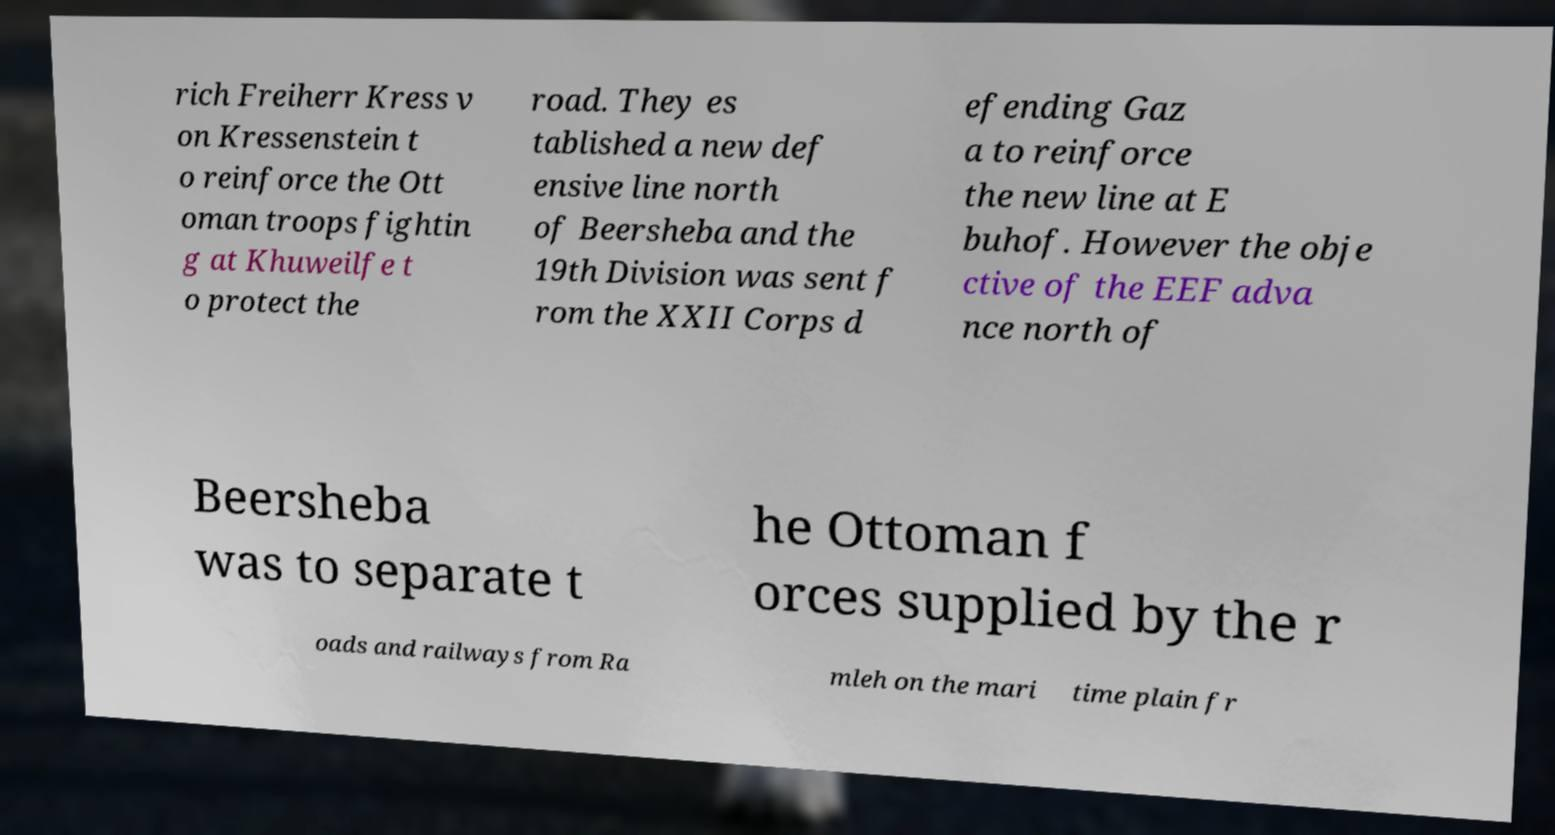There's text embedded in this image that I need extracted. Can you transcribe it verbatim? rich Freiherr Kress v on Kressenstein t o reinforce the Ott oman troops fightin g at Khuweilfe t o protect the road. They es tablished a new def ensive line north of Beersheba and the 19th Division was sent f rom the XXII Corps d efending Gaz a to reinforce the new line at E buhof. However the obje ctive of the EEF adva nce north of Beersheba was to separate t he Ottoman f orces supplied by the r oads and railways from Ra mleh on the mari time plain fr 